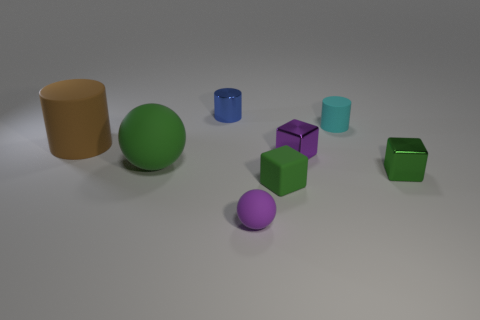The green block that is the same material as the large brown thing is what size?
Provide a short and direct response. Small. Is the number of big blue rubber cylinders greater than the number of tiny matte balls?
Your response must be concise. No. What material is the cyan cylinder that is the same size as the purple ball?
Offer a very short reply. Rubber. There is a rubber object behind the brown rubber thing; does it have the same size as the small blue cylinder?
Ensure brevity in your answer.  Yes. How many cubes are cyan rubber things or small purple rubber things?
Make the answer very short. 0. What material is the green block on the left side of the cyan cylinder?
Your answer should be compact. Rubber. Are there fewer big cylinders than big cyan shiny balls?
Provide a short and direct response. No. There is a cylinder that is to the left of the cyan rubber thing and to the right of the big brown matte cylinder; what size is it?
Your answer should be compact. Small. How big is the metallic thing that is behind the rubber cylinder that is in front of the tiny cylinder that is to the right of the small purple rubber object?
Your answer should be very brief. Small. What number of other objects are the same color as the small metal cylinder?
Offer a very short reply. 0. 